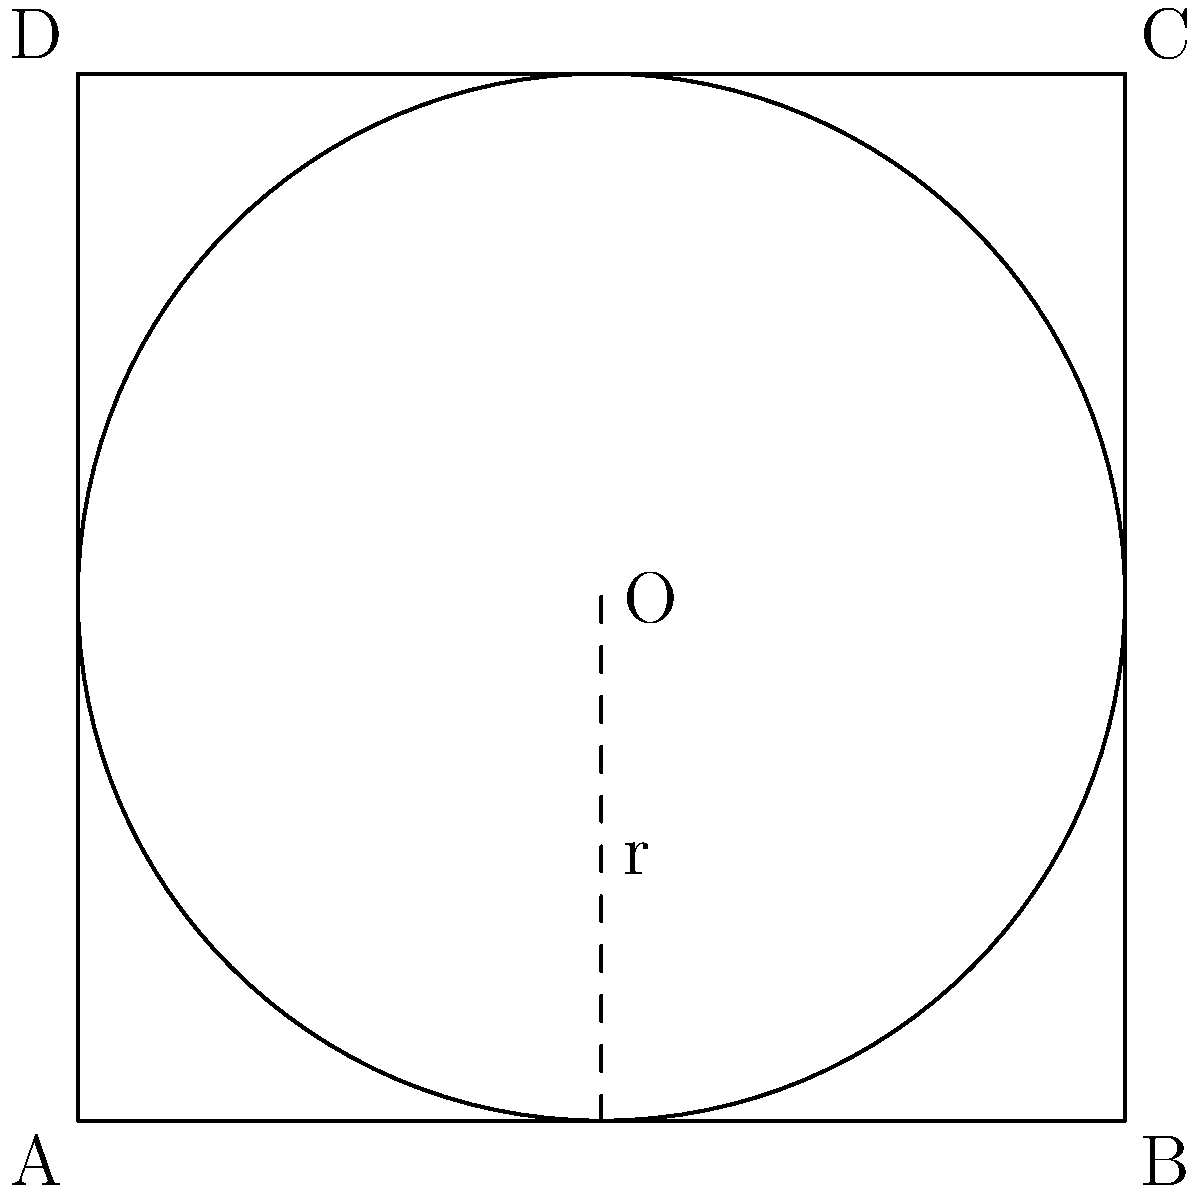In the figure above, a circle is inscribed in a square ABCD. If the side length of the square is 4 units, what is the circumference of the inscribed circle? Express your answer in terms of $\pi$. Let's approach this step-by-step:

1) First, we need to find the radius of the inscribed circle.

2) In an inscribed circle, the radius is perpendicular to the sides of the square and touches the midpoint of each side.

3) The diameter of the circle is equal to the side length of the square.

4) Given that the side length of the square is 4 units, the diameter of the circle is also 4 units.

5) Therefore, the radius of the circle is half of this, which is 2 units.

6) Now that we have the radius, we can calculate the circumference using the formula:

   $C = 2\pi r$

   where $C$ is the circumference, $r$ is the radius, and $\pi$ is pi.

7) Substituting $r = 2$ into the formula:

   $C = 2\pi(2) = 4\pi$

Thus, the circumference of the inscribed circle is $4\pi$ units.
Answer: $4\pi$ units 